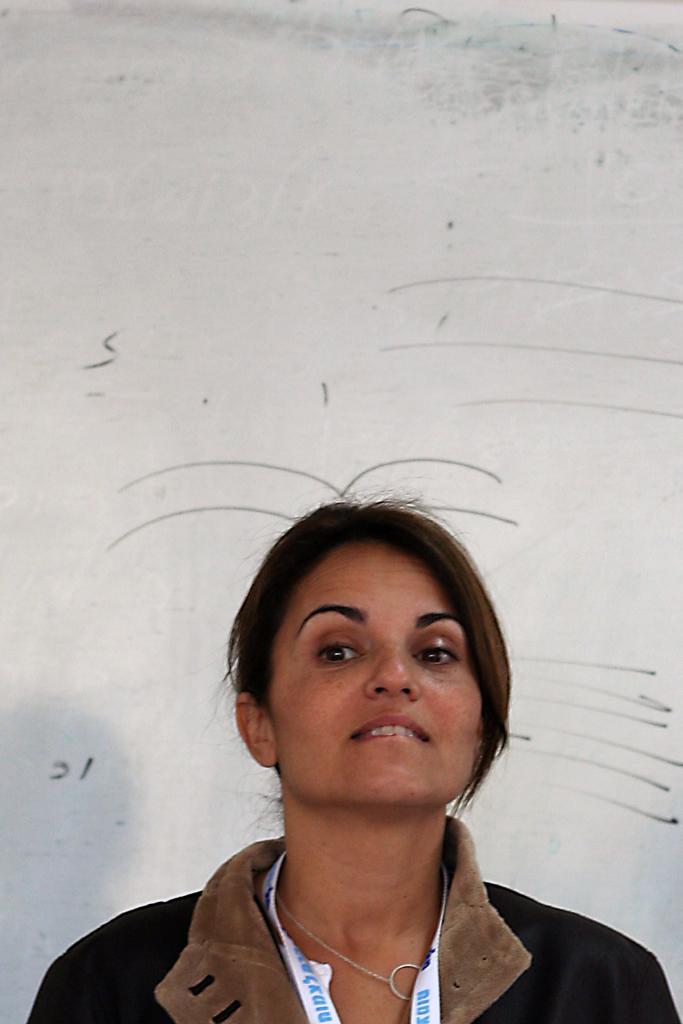Describe this image in one or two sentences. In this image we can see a woman wearing jacket, identity card and chain is standing here. In the background, we can see the wall on which we can see some drawings. 